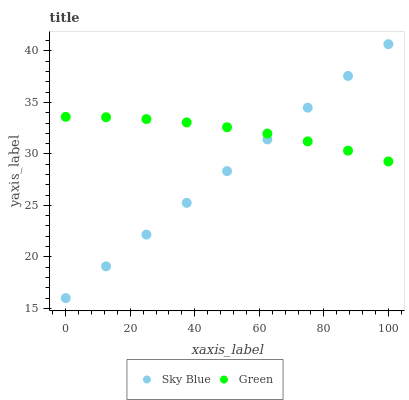Does Sky Blue have the minimum area under the curve?
Answer yes or no. Yes. Does Green have the maximum area under the curve?
Answer yes or no. Yes. Does Green have the minimum area under the curve?
Answer yes or no. No. Is Sky Blue the smoothest?
Answer yes or no. Yes. Is Green the roughest?
Answer yes or no. Yes. Is Green the smoothest?
Answer yes or no. No. Does Sky Blue have the lowest value?
Answer yes or no. Yes. Does Green have the lowest value?
Answer yes or no. No. Does Sky Blue have the highest value?
Answer yes or no. Yes. Does Green have the highest value?
Answer yes or no. No. Does Sky Blue intersect Green?
Answer yes or no. Yes. Is Sky Blue less than Green?
Answer yes or no. No. Is Sky Blue greater than Green?
Answer yes or no. No. 